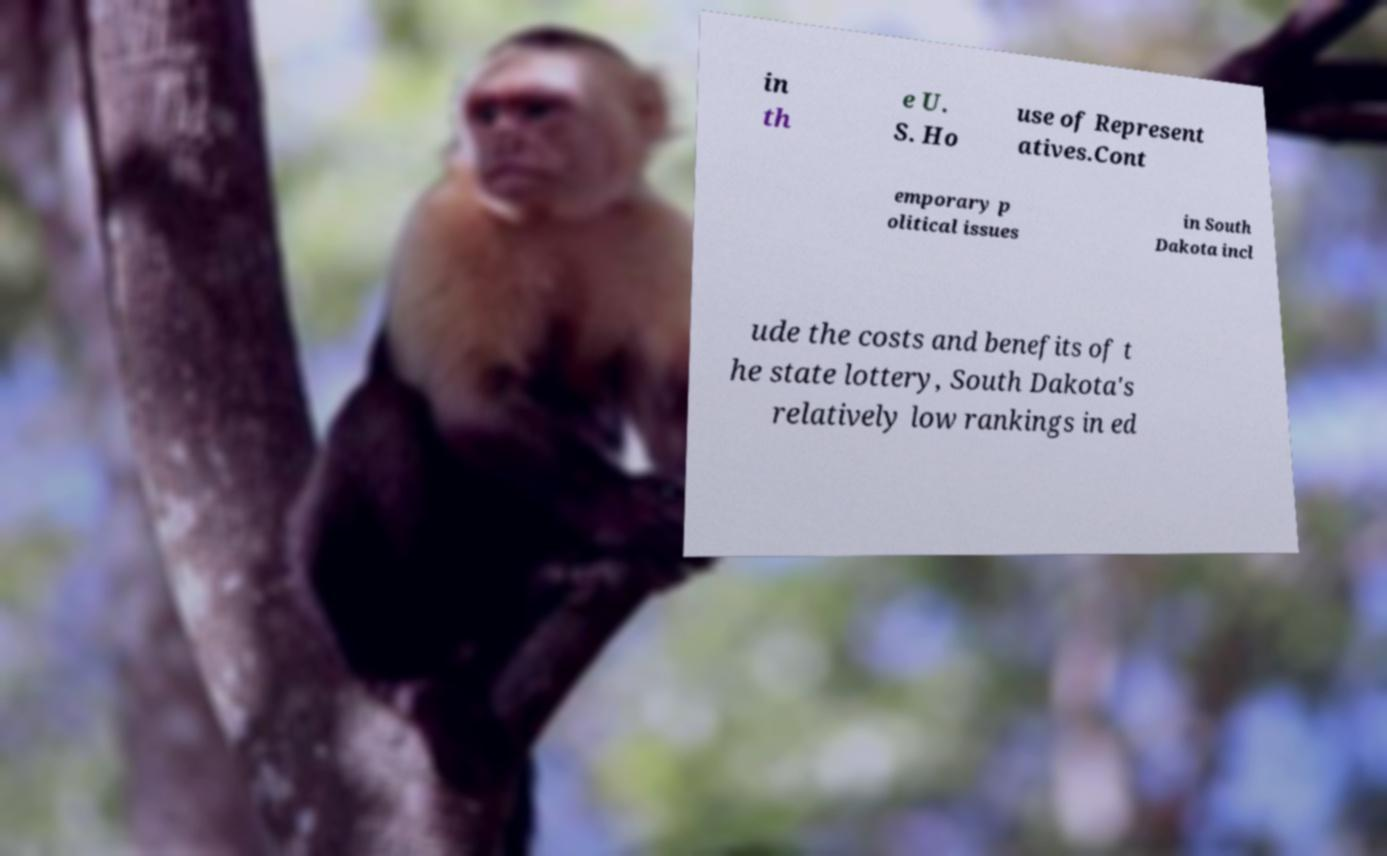Please read and relay the text visible in this image. What does it say? in th e U. S. Ho use of Represent atives.Cont emporary p olitical issues in South Dakota incl ude the costs and benefits of t he state lottery, South Dakota's relatively low rankings in ed 